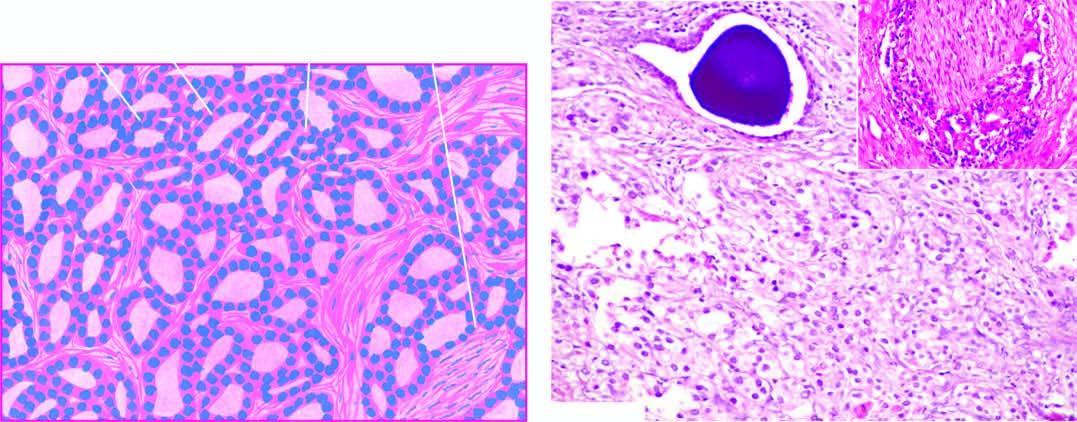what shows perineural invasion by prostatic adenocarcinoma?
Answer the question using a single word or phrase. Inset in the photomicrograph 